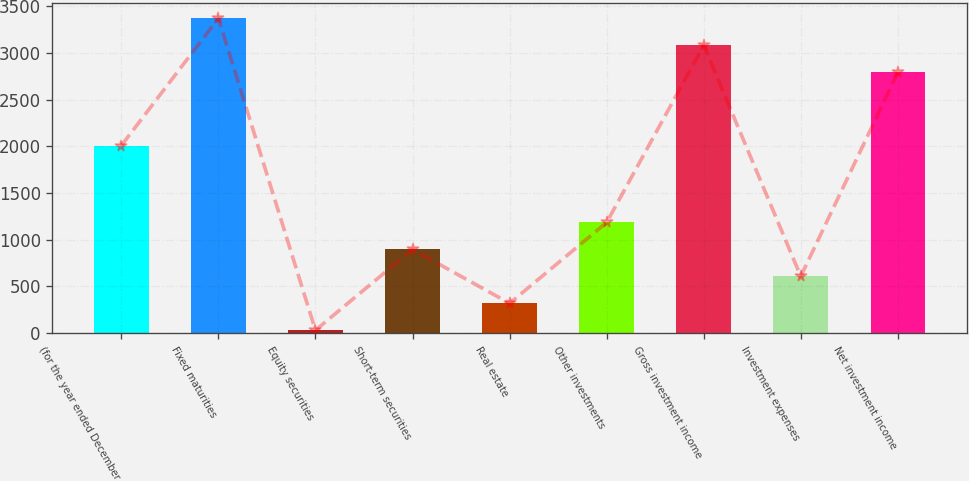Convert chart to OTSL. <chart><loc_0><loc_0><loc_500><loc_500><bar_chart><fcel>(for the year ended December<fcel>Fixed maturities<fcel>Equity securities<fcel>Short-term securities<fcel>Real estate<fcel>Other investments<fcel>Gross investment income<fcel>Investment expenses<fcel>Net investment income<nl><fcel>2008<fcel>3368.8<fcel>31<fcel>896.2<fcel>319.4<fcel>1184.6<fcel>3080.4<fcel>607.8<fcel>2792<nl></chart> 